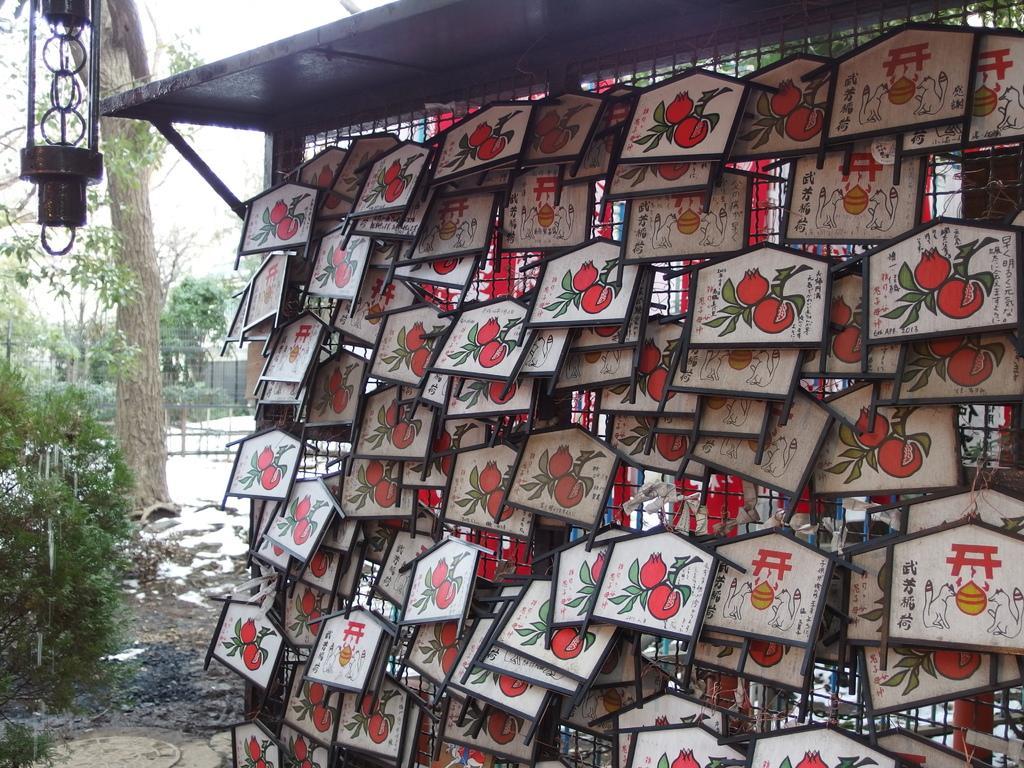Please provide a concise description of this image. In this image we can see a mesh wall. On that there are many boards hanged. On the boards there are images. On the right side there are trees. Also we can see an object at the top. 